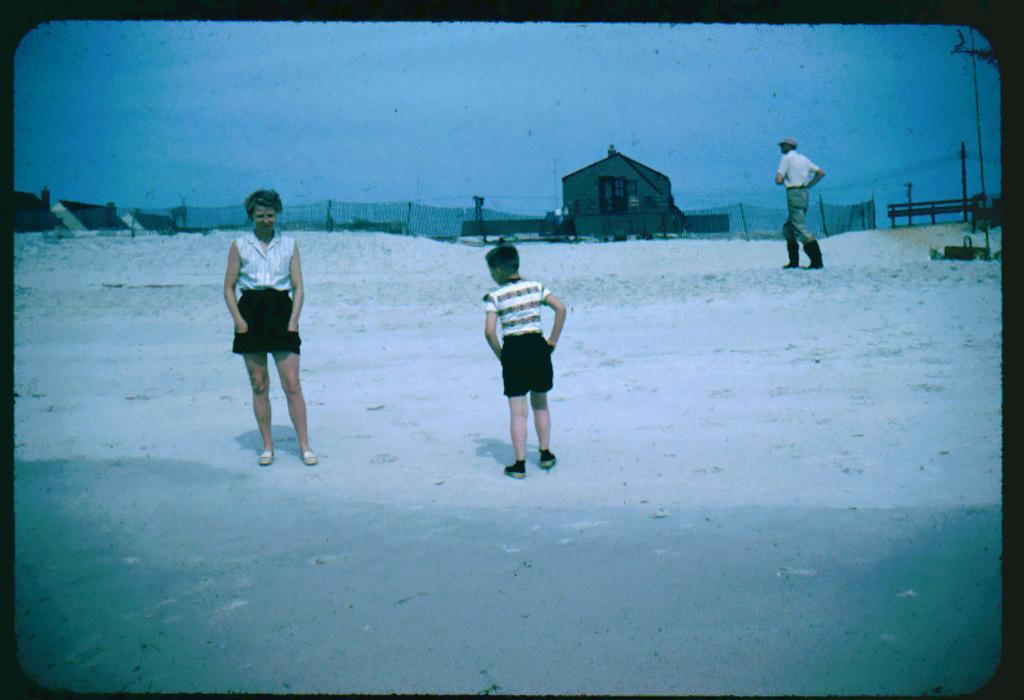Can you describe this image briefly? This is an edited image. I can see two persons standing and a person walking on the snow. On the right side of the image, there is a bench. I can see the houses and fence. In the background, there is the sky. 